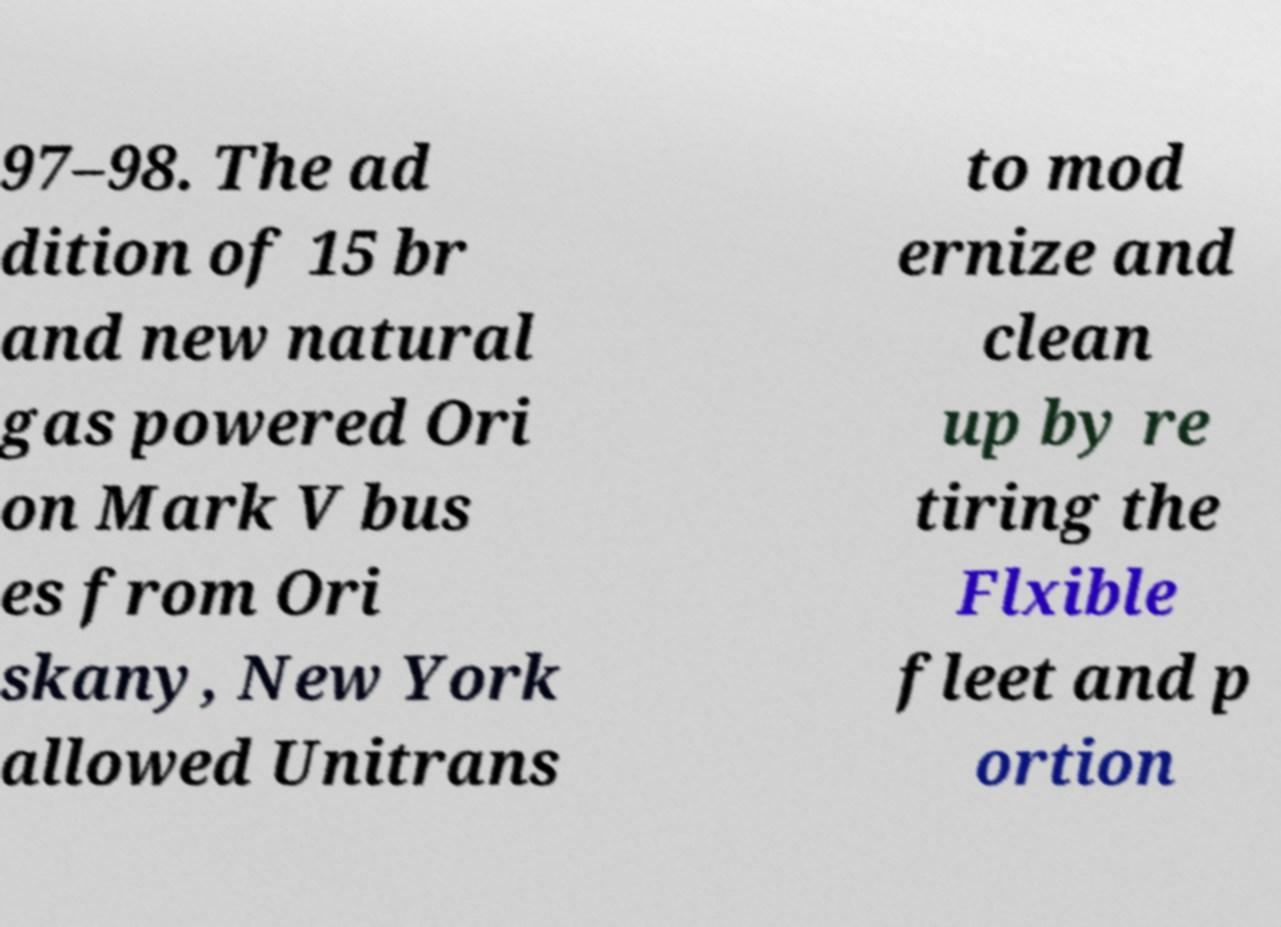I need the written content from this picture converted into text. Can you do that? 97–98. The ad dition of 15 br and new natural gas powered Ori on Mark V bus es from Ori skany, New York allowed Unitrans to mod ernize and clean up by re tiring the Flxible fleet and p ortion 